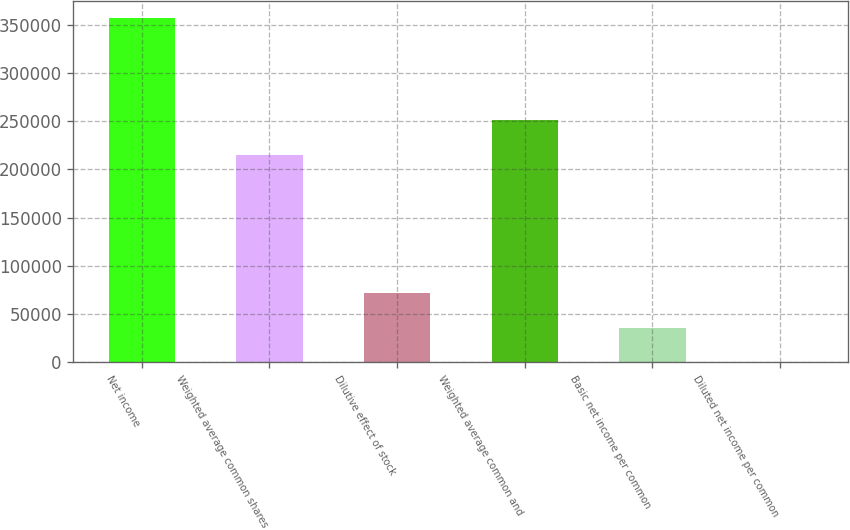Convert chart. <chart><loc_0><loc_0><loc_500><loc_500><bar_chart><fcel>Net income<fcel>Weighted average common shares<fcel>Dilutive effect of stock<fcel>Weighted average common and<fcel>Basic net income per common<fcel>Diluted net income per common<nl><fcel>357029<fcel>215498<fcel>71407.1<fcel>251201<fcel>35704.4<fcel>1.62<nl></chart> 